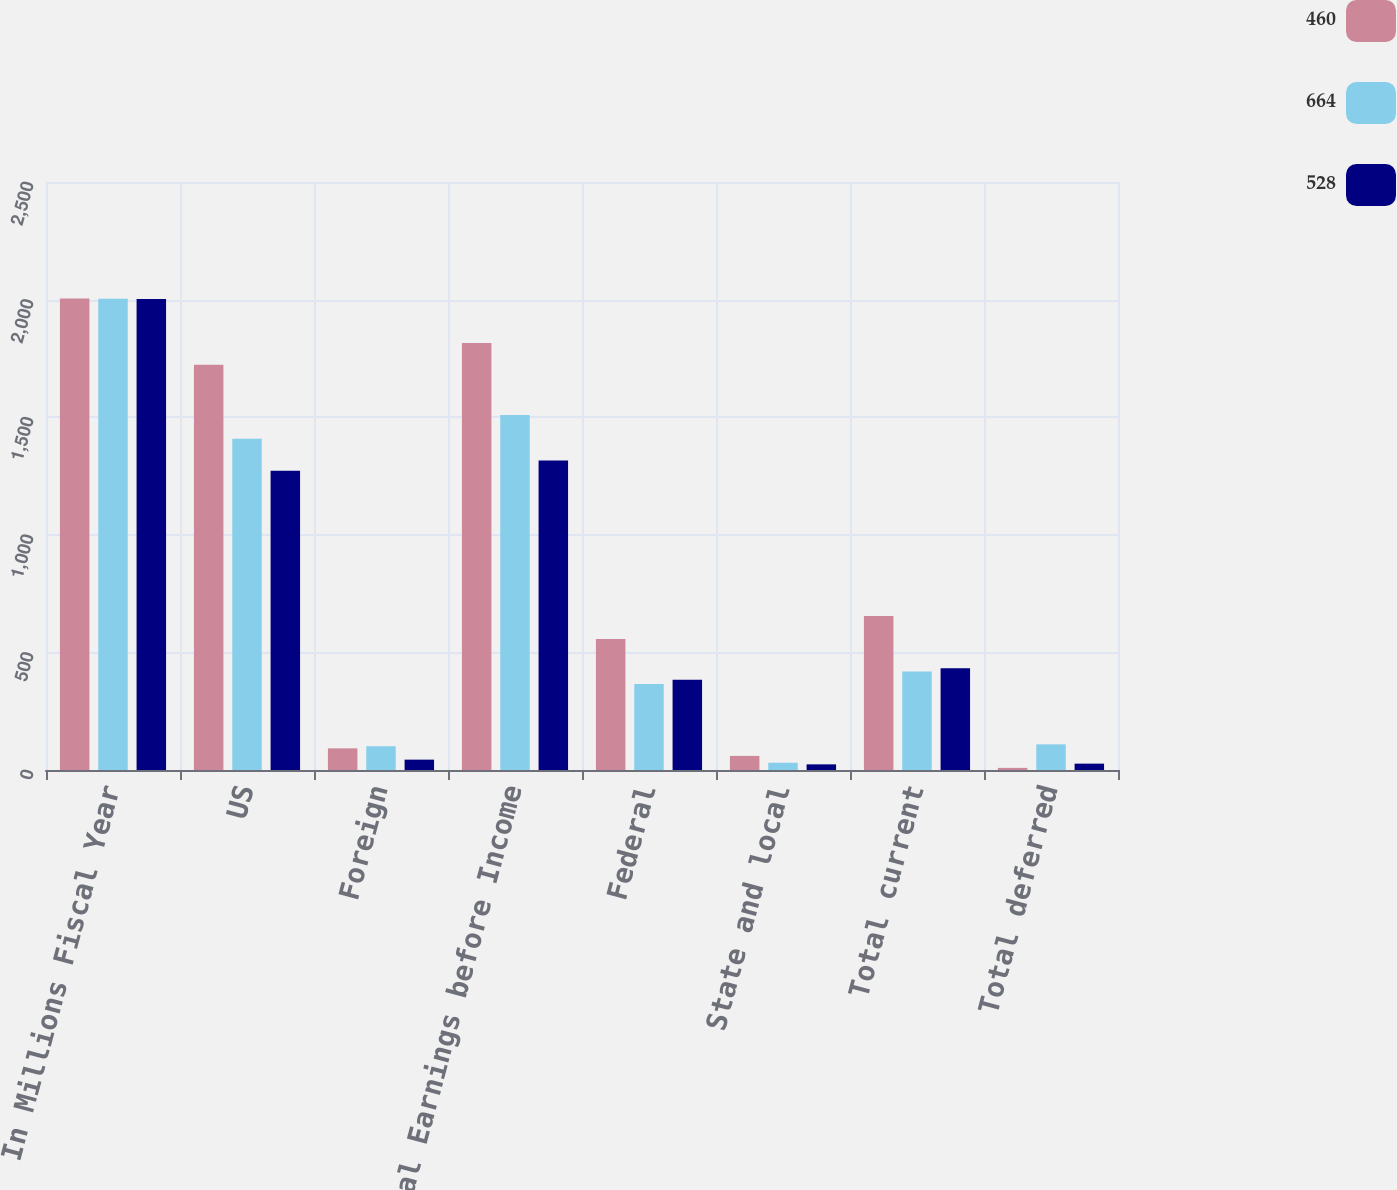Convert chart to OTSL. <chart><loc_0><loc_0><loc_500><loc_500><stacked_bar_chart><ecel><fcel>In Millions Fiscal Year<fcel>US<fcel>Foreign<fcel>Total Earnings before Income<fcel>Federal<fcel>State and local<fcel>Total current<fcel>Total deferred<nl><fcel>460<fcel>2005<fcel>1723<fcel>92<fcel>1815<fcel>557<fcel>60<fcel>655<fcel>9<nl><fcel>664<fcel>2004<fcel>1408<fcel>101<fcel>1509<fcel>366<fcel>31<fcel>419<fcel>109<nl><fcel>528<fcel>2003<fcel>1272<fcel>44<fcel>1316<fcel>384<fcel>24<fcel>433<fcel>27<nl></chart> 